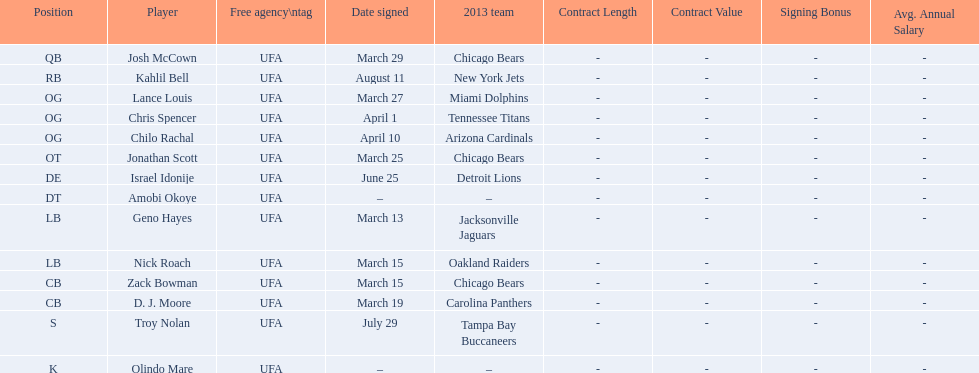What is the total of 2013 teams on the chart? 10. 